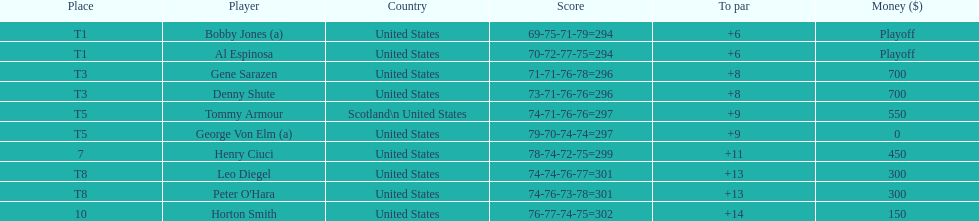What was al espinosa's overall stroke tally at the end of the 1929 us open? 294. 